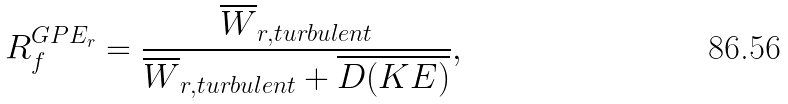Convert formula to latex. <formula><loc_0><loc_0><loc_500><loc_500>R _ { f } ^ { G P E _ { r } } = \frac { \overline { W } _ { r , t u r b u l e n t } } { \overline { W } _ { r , t u r b u l e n t } + \overline { D ( K E ) } } ,</formula> 